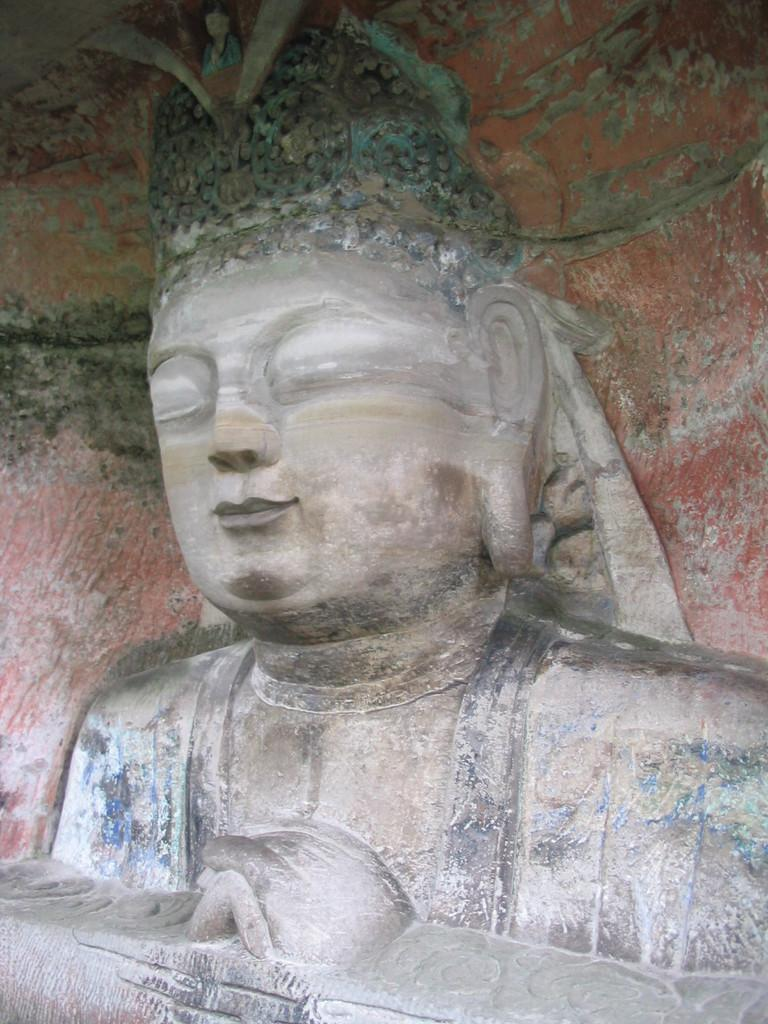What is the main subject in the center of the image? There is a statue in the center of the image. Where is the statue located? The statue is on the wall. What type of pot is visible near the statue in the image? There is no pot visible near the statue in the image. Can you hear the ducks quacking in the image? There are no ducks present in the image, so it is not possible to hear them quacking. 